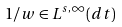<formula> <loc_0><loc_0><loc_500><loc_500>1 / w \in L ^ { s , \infty } ( d t )</formula> 